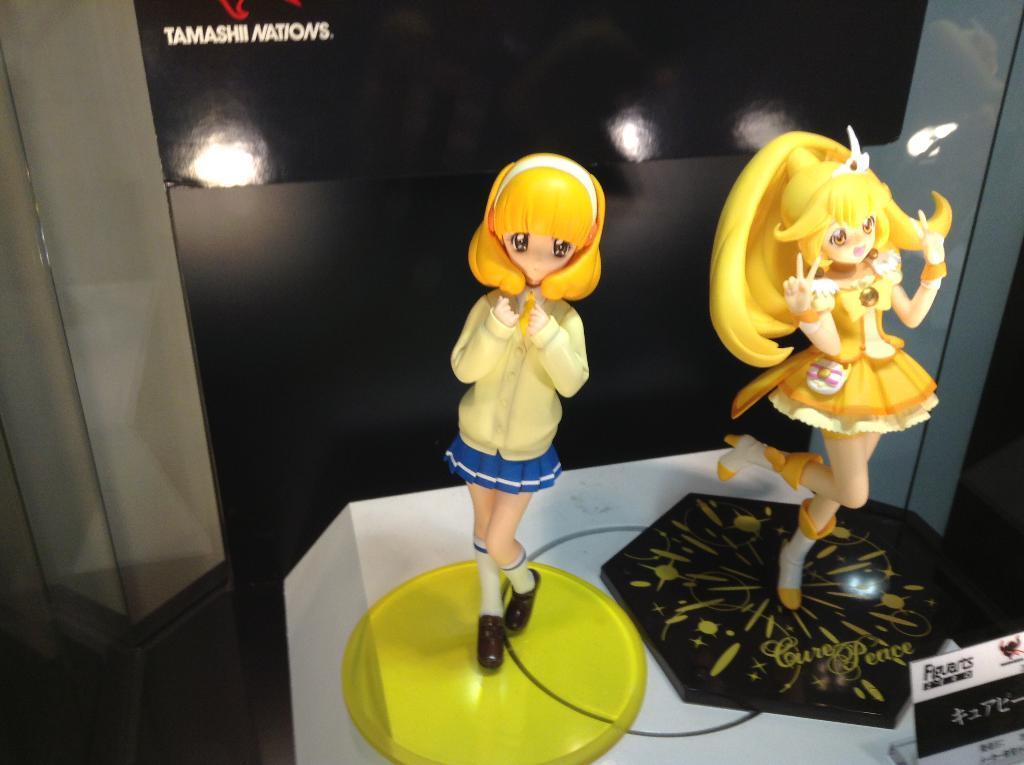Please provide a concise description of this image. In this image there are toys, boards and objects. Something is written on the boards. 